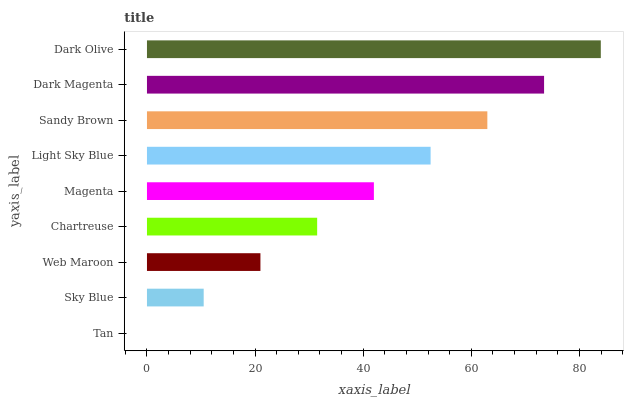Is Tan the minimum?
Answer yes or no. Yes. Is Dark Olive the maximum?
Answer yes or no. Yes. Is Sky Blue the minimum?
Answer yes or no. No. Is Sky Blue the maximum?
Answer yes or no. No. Is Sky Blue greater than Tan?
Answer yes or no. Yes. Is Tan less than Sky Blue?
Answer yes or no. Yes. Is Tan greater than Sky Blue?
Answer yes or no. No. Is Sky Blue less than Tan?
Answer yes or no. No. Is Magenta the high median?
Answer yes or no. Yes. Is Magenta the low median?
Answer yes or no. Yes. Is Sky Blue the high median?
Answer yes or no. No. Is Web Maroon the low median?
Answer yes or no. No. 